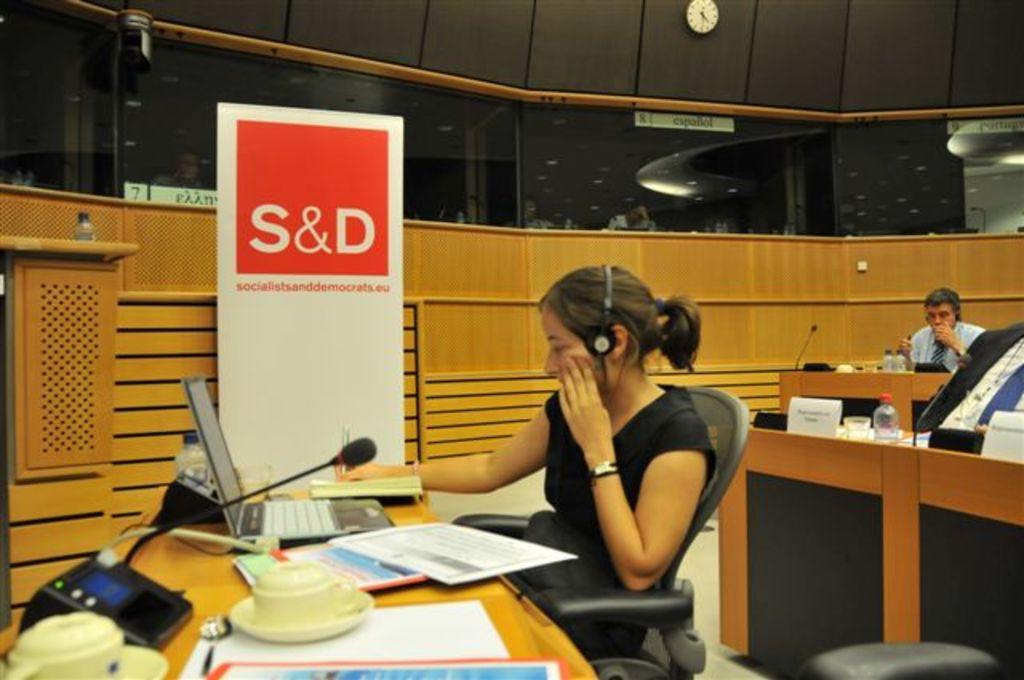How would you summarize this image in a sentence or two? In this image we can see a lady wearing headphones and sitting on a chair. In front of her there is a table on which there is a laptop, books and other objects. In the background of the image there is a wooden wall. There is a banner with some text. There is a clock. To the right side of the image there is a person and there is a table with bottles and mic. 